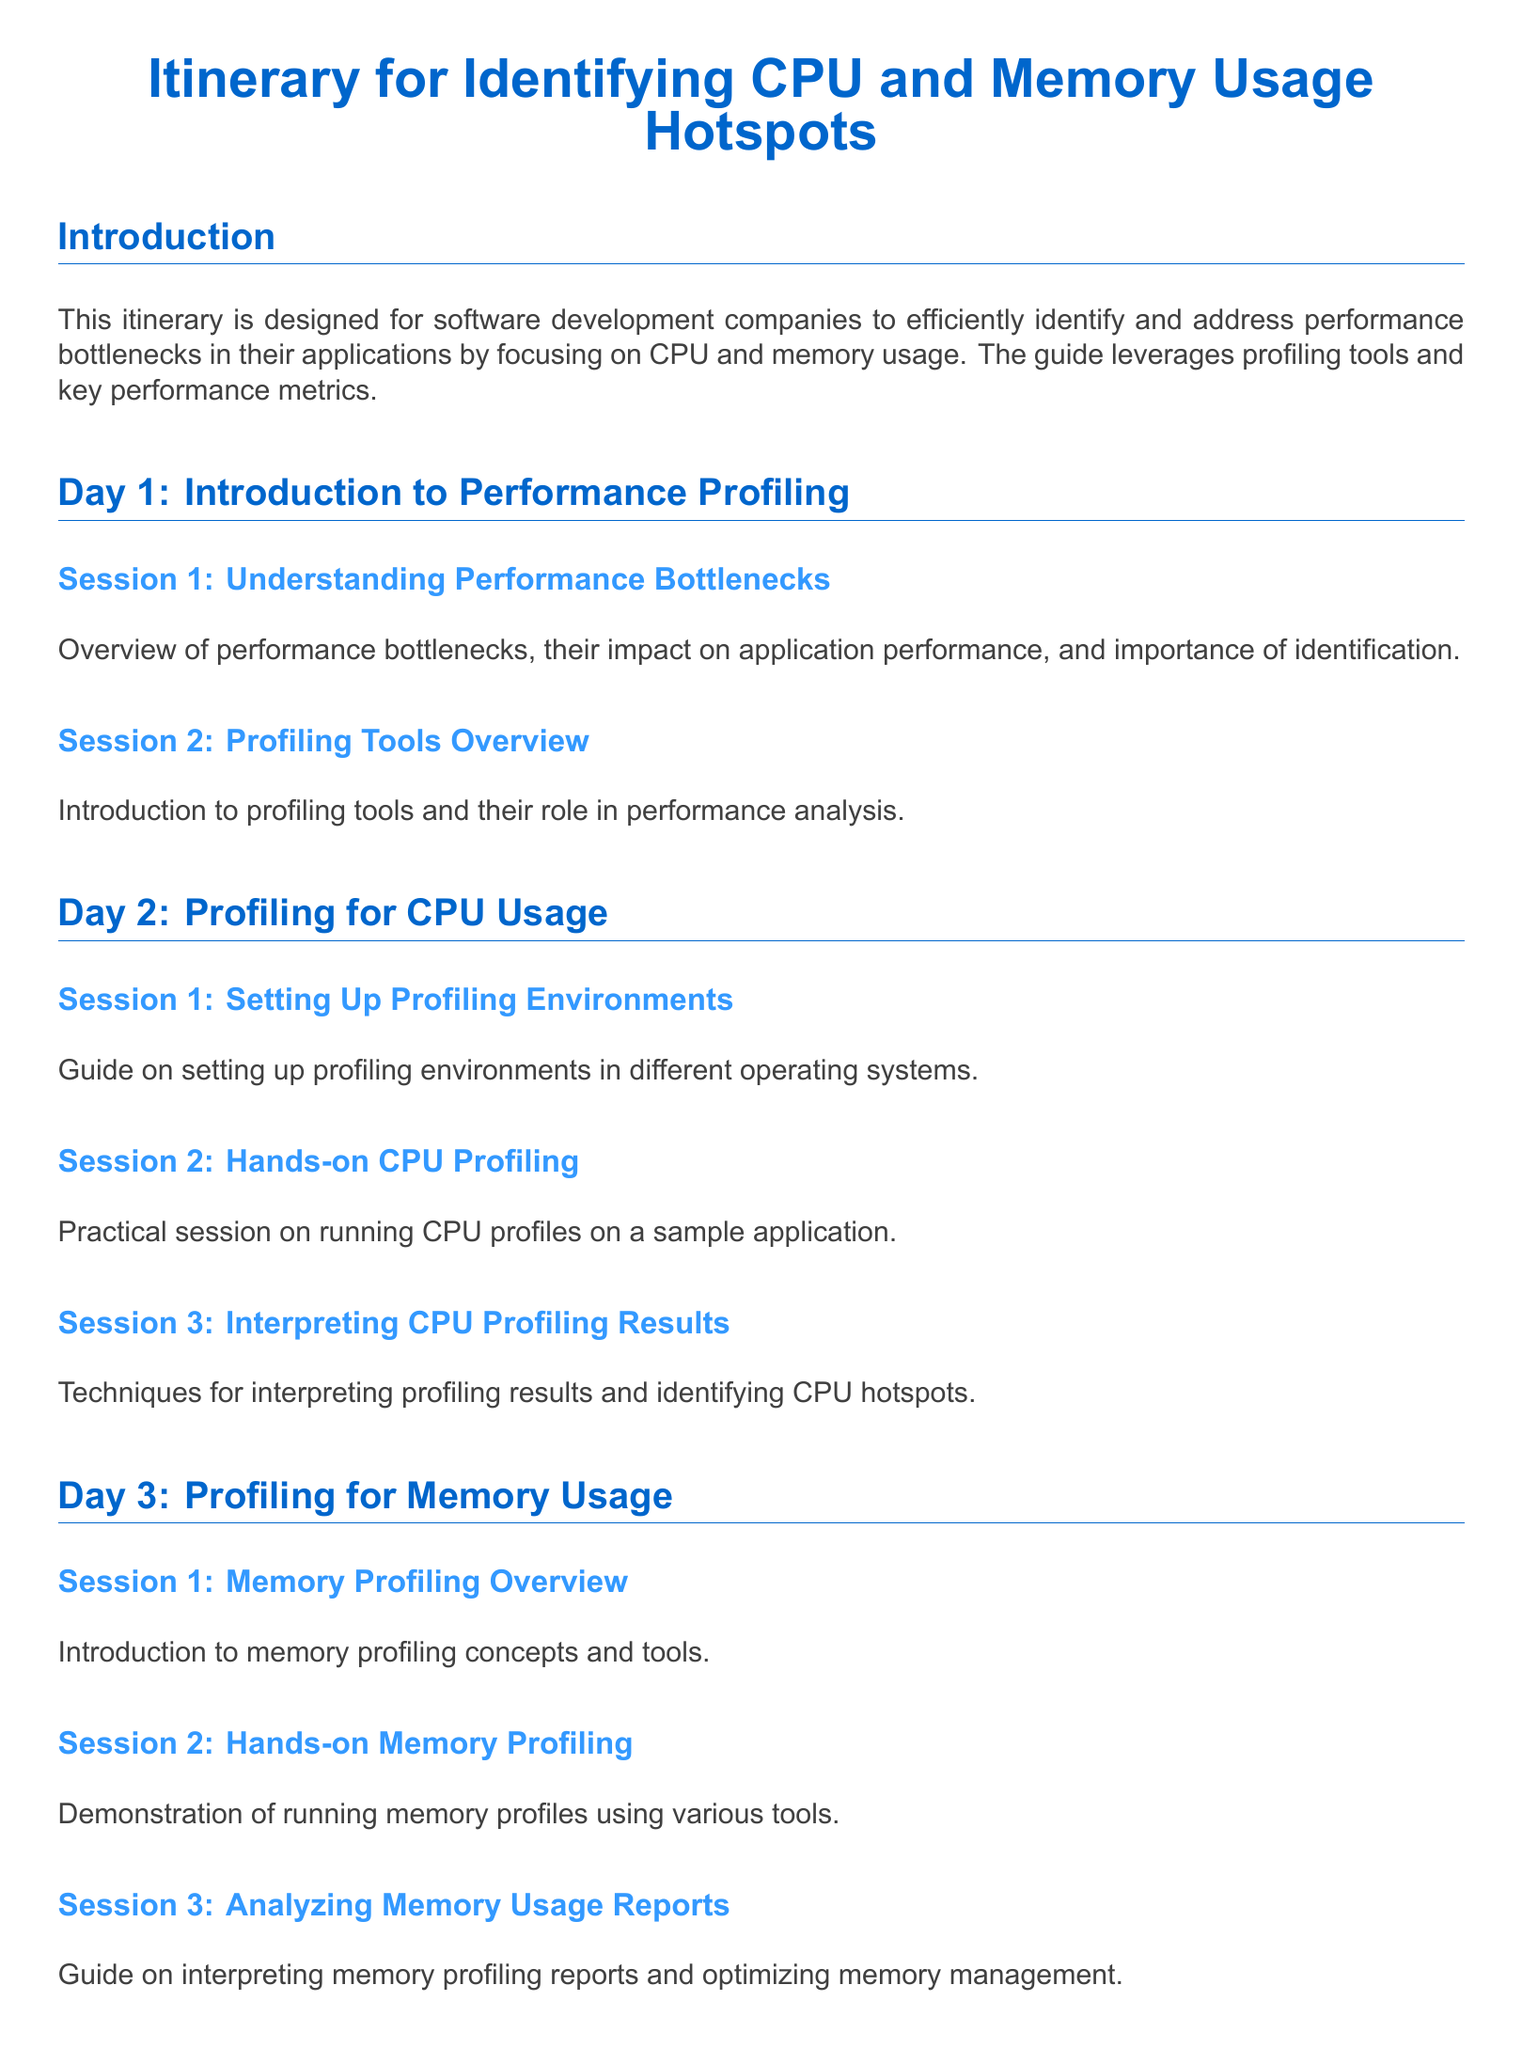What is the title of the itinerary? The title of the itinerary is the main heading presented at the top of the document.
Answer: Itinerary for Identifying CPU and Memory Usage Hotspots How many days is the itinerary designed for? The document specifies a structured outline that spans over several days.
Answer: 5 What session focuses on memory management optimization? This session relates to interpreting profiling reports for effective memory usage and management strategies.
Answer: Analyzing Memory Usage Reports What is covered in Day 2, Session 3? This session is dedicated to techniques for analyzing and interpreting the results from CPU profiling.
Answer: Interpreting CPU Profiling Results What is the main emphasis of Day 4, Session 2? This session mentions recommended approaches and strategies for continual performance assessment.
Answer: Best Practices and Optimization Strategies How does the itinerary conclude? The conclusion summarizes the expected outcomes and benefits of following the outlined itinerary.
Answer: Improved application performance and user satisfaction What practical skill is developed on Day 3? The itinerary mentions a practical aspect relating to the hands-on approach to analyzing memory usage.
Answer: Hands-on Memory Profiling What type of analysis is tackled in the last session? The final session includes a detailed examination of a practical case study to reinforce learning.
Answer: Case Study Analysis 